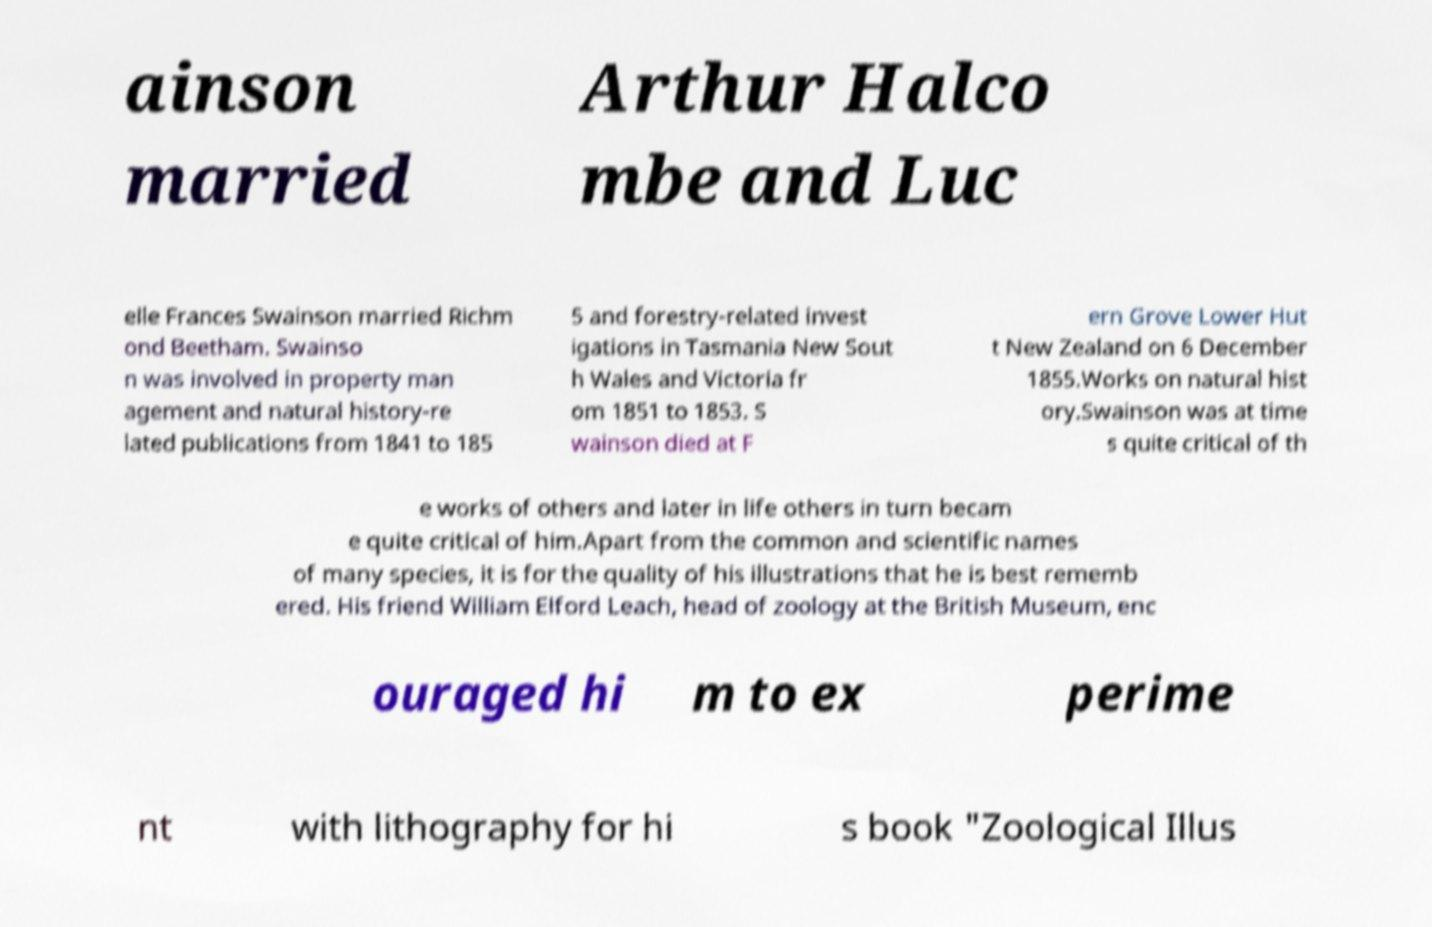I need the written content from this picture converted into text. Can you do that? ainson married Arthur Halco mbe and Luc elle Frances Swainson married Richm ond Beetham. Swainso n was involved in property man agement and natural history-re lated publications from 1841 to 185 5 and forestry-related invest igations in Tasmania New Sout h Wales and Victoria fr om 1851 to 1853. S wainson died at F ern Grove Lower Hut t New Zealand on 6 December 1855.Works on natural hist ory.Swainson was at time s quite critical of th e works of others and later in life others in turn becam e quite critical of him.Apart from the common and scientific names of many species, it is for the quality of his illustrations that he is best rememb ered. His friend William Elford Leach, head of zoology at the British Museum, enc ouraged hi m to ex perime nt with lithography for hi s book "Zoological Illus 